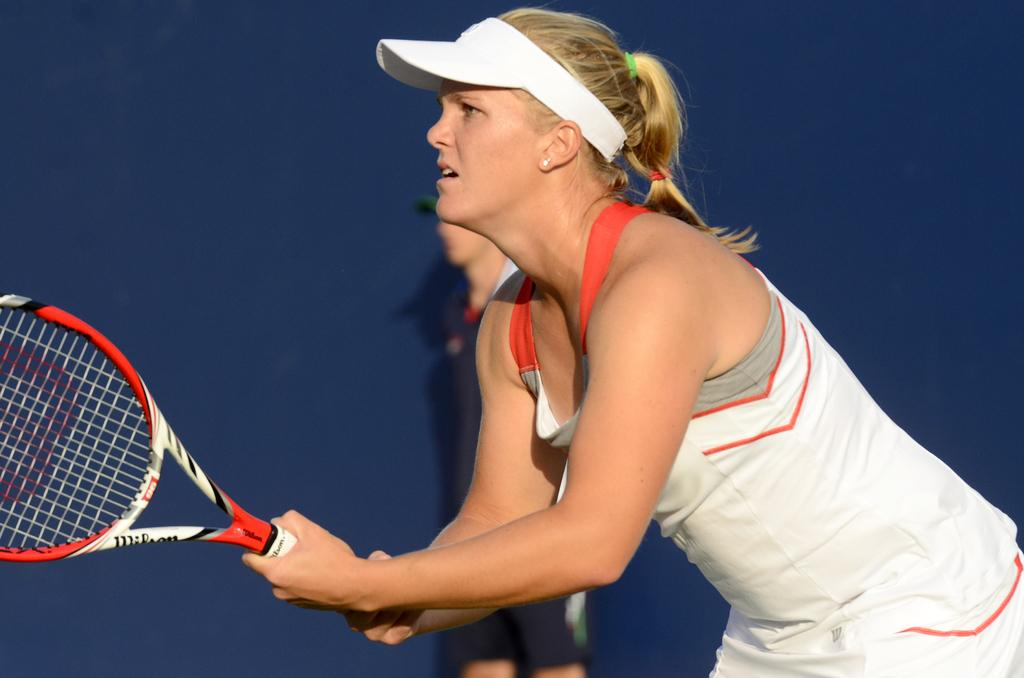Who is the main subject in the image? There is a woman in the image. What is the woman holding in her hands? The woman is holding a racket in her hands. What type of clothing is the woman wearing? The woman is wearing a sports dress. Can you describe the background of the image? There is a person visible in the background of the image. What type of truck can be seen in the image? There is no truck present in the image. What pest is the woman trying to get rid of in the image? There is no pest visible in the image. 